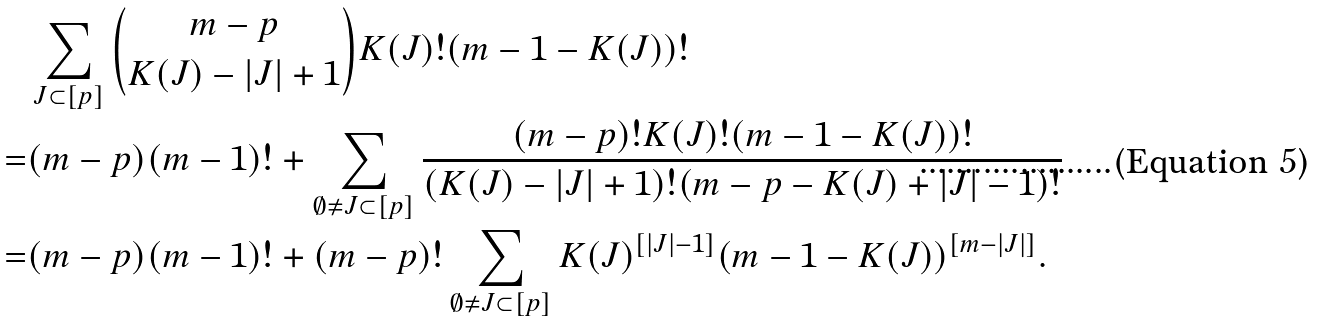Convert formula to latex. <formula><loc_0><loc_0><loc_500><loc_500>& \sum _ { J \subset [ p ] } \binom { m - p } { K ( J ) - | J | + 1 } K ( J ) ! ( m - 1 - K ( J ) ) ! \\ = & ( m - p ) ( m - 1 ) ! + \sum _ { \emptyset \neq J \subset [ p ] } \frac { ( m - p ) ! K ( J ) ! ( m - 1 - K ( J ) ) ! } { ( K ( J ) - | J | + 1 ) ! ( m - p - K ( J ) + | J | - 1 ) ! } \\ = & ( m - p ) ( m - 1 ) ! + ( m - p ) ! \sum _ { \emptyset \neq J \subset [ p ] } K ( J ) ^ { [ | J | - 1 ] } ( m - 1 - K ( J ) ) ^ { [ m - | J | ] } .</formula> 